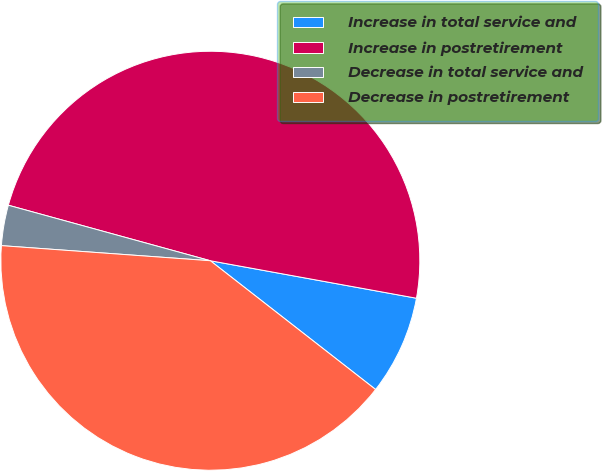Convert chart to OTSL. <chart><loc_0><loc_0><loc_500><loc_500><pie_chart><fcel>Increase in total service and<fcel>Increase in postretirement<fcel>Decrease in total service and<fcel>Decrease in postretirement<nl><fcel>7.67%<fcel>48.59%<fcel>3.12%<fcel>40.61%<nl></chart> 